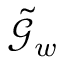Convert formula to latex. <formula><loc_0><loc_0><loc_500><loc_500>\tilde { \mathcal { G } } _ { w }</formula> 